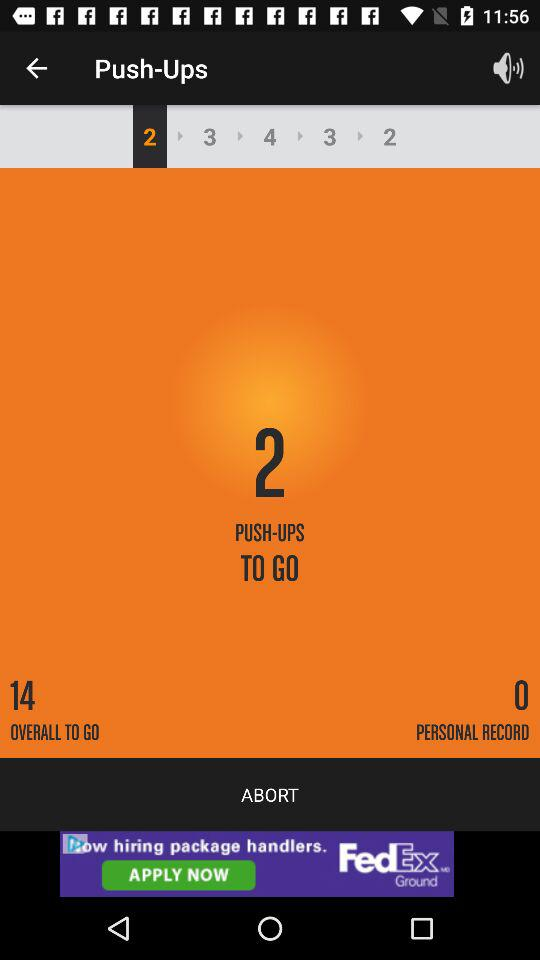Which tab is currently selected?
When the provided information is insufficient, respond with <no answer>. <no answer> 